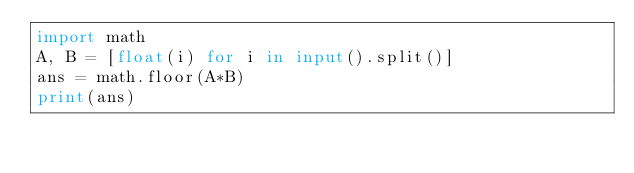Convert code to text. <code><loc_0><loc_0><loc_500><loc_500><_Python_>import math
A, B = [float(i) for i in input().split()]
ans = math.floor(A*B)
print(ans)</code> 